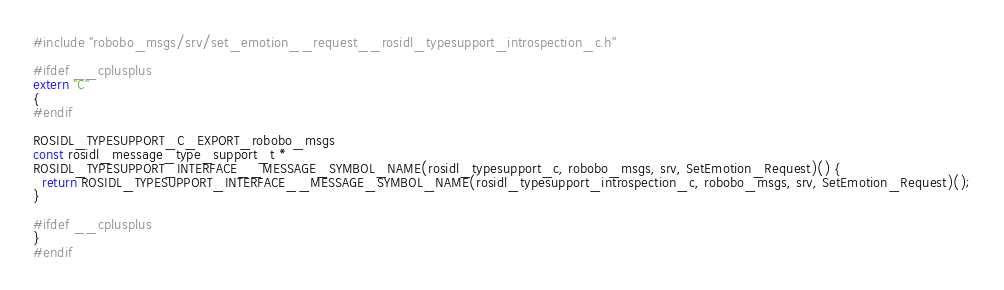Convert code to text. <code><loc_0><loc_0><loc_500><loc_500><_C++_>#include "robobo_msgs/srv/set_emotion__request__rosidl_typesupport_introspection_c.h"

#ifdef __cplusplus
extern "C"
{
#endif

ROSIDL_TYPESUPPORT_C_EXPORT_robobo_msgs
const rosidl_message_type_support_t *
ROSIDL_TYPESUPPORT_INTERFACE__MESSAGE_SYMBOL_NAME(rosidl_typesupport_c, robobo_msgs, srv, SetEmotion_Request)() {
  return ROSIDL_TYPESUPPORT_INTERFACE__MESSAGE_SYMBOL_NAME(rosidl_typesupport_introspection_c, robobo_msgs, srv, SetEmotion_Request)();
}

#ifdef __cplusplus
}
#endif
</code> 